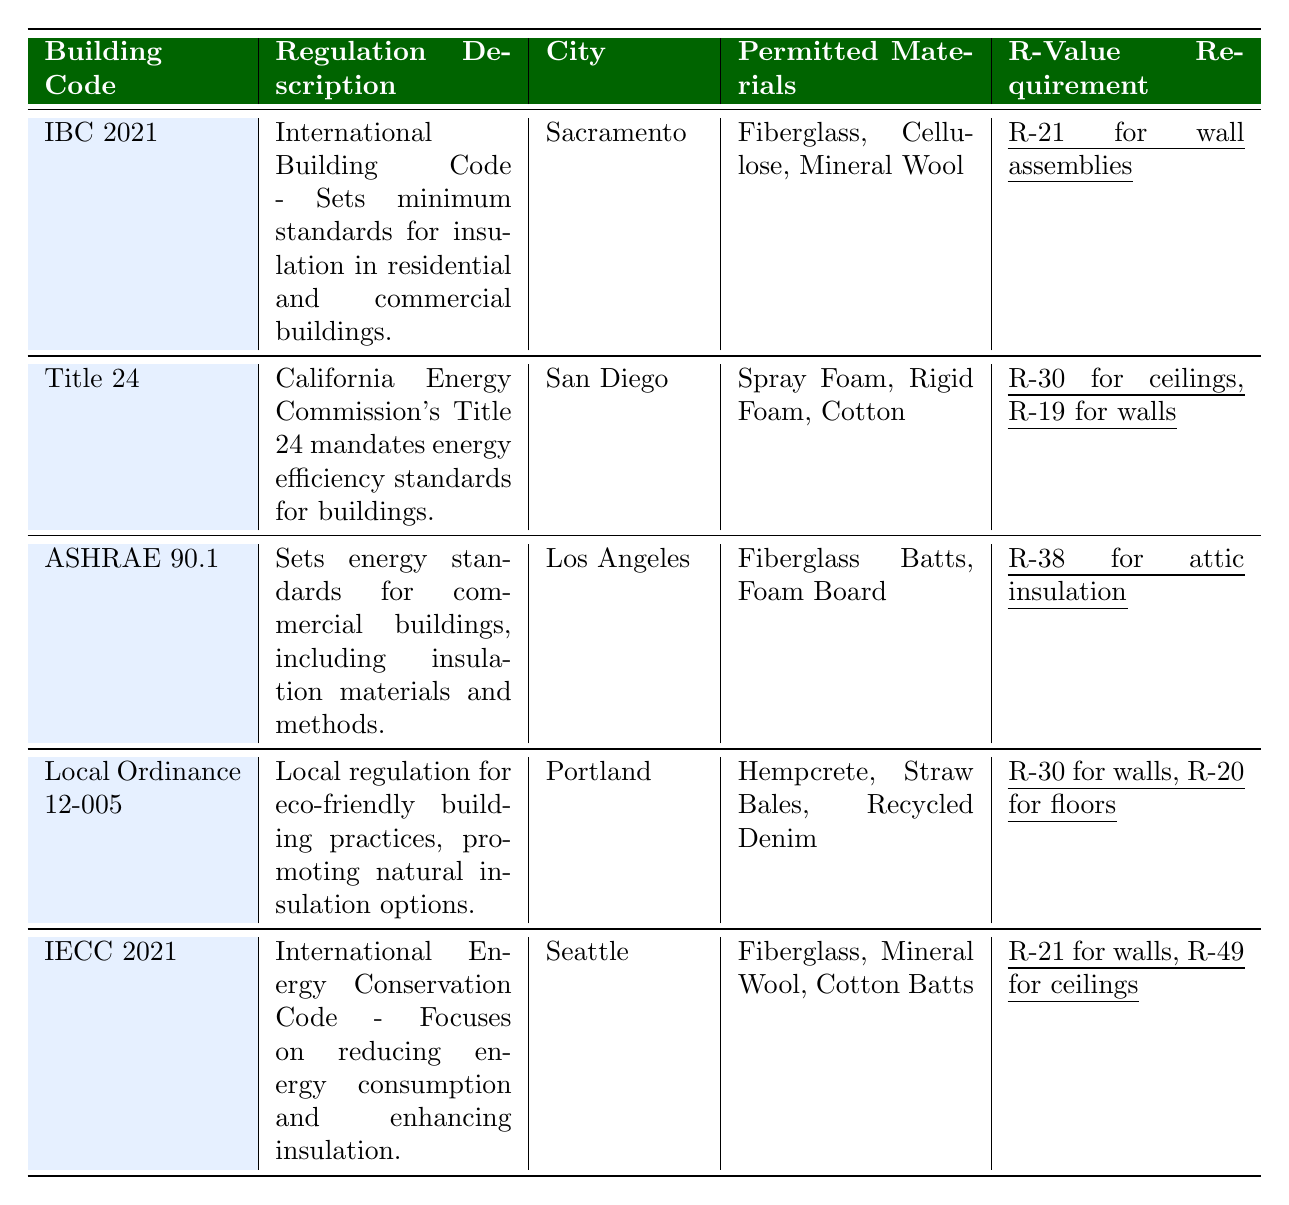What is the R-Value requirement for wall assemblies in Sacramento? The table states the R-Value requirement for wall assemblies under the IBC 2021 regulation in Sacramento is R-21.
Answer: R-21 Which materials are permitted under the Title 24 regulation in San Diego? The table lists the permitted materials under the Title 24 regulation in San Diego as Spray Foam, Rigid Foam, and Cotton.
Answer: Spray Foam, Rigid Foam, Cotton Is Hempcrete a permitted material under the IBC 2021 regulation? According to the table, Hempcrete is not listed as a permitted material under the IBC 2021 regulation; it is found under Local Ordinance 12-005 instead.
Answer: No What is the combined R-Value requirement for walls and ceilings in San Diego? The R-Value requirement for walls in San Diego is R-19, and for ceilings, it is R-30. The combined requirement is 19 + 30 = 49.
Answer: R-49 Which city has the highest R-Value requirement for attic insulation? The table shows that Los Angeles has the highest R-Value requirement for attic insulation, which is R-38 as per the ASHRAE 90.1 regulation.
Answer: Los Angeles In which city can you use mineral wool as an insulation material? The table indicates that mineral wool is permitted in Sacramento under the IBC 2021 and also in Seattle under the IECC 2021.
Answer: Sacramento and Seattle How do the R-Value requirements for walls in Portland compare to those in Seattle? Portland's R-Value requirement for walls is R-30, while Seattle's is R-21. Since R-30 is higher than R-21, Portland has a stricter requirement.
Answer: Portland has a higher requirement What variety of insulation materials is allowed by the Local Ordinance 12-005 in Portland? The table lists the permitted materials under Local Ordinance 12-005 in Portland as Hempcrete, Straw Bales, and Recycled Denim.
Answer: Hempcrete, Straw Bales, Recycled Denim Which building code has the lowest R-Value requirement for walls? The table reveals that the IECC 2021 regulation requires R-21 for walls, which is the lowest compared to the other codes.
Answer: IECC 2021 Are all the permitted materials in Seattle also permitted in Los Angeles? The table shows Seattle allows Fiberglass, Mineral Wool, and Cotton Batts, while Los Angeles permits Fiberglass Batts and Foam Board. Therefore, some materials (Fiberglass) are common, but not all are permitted in both cities.
Answer: No 